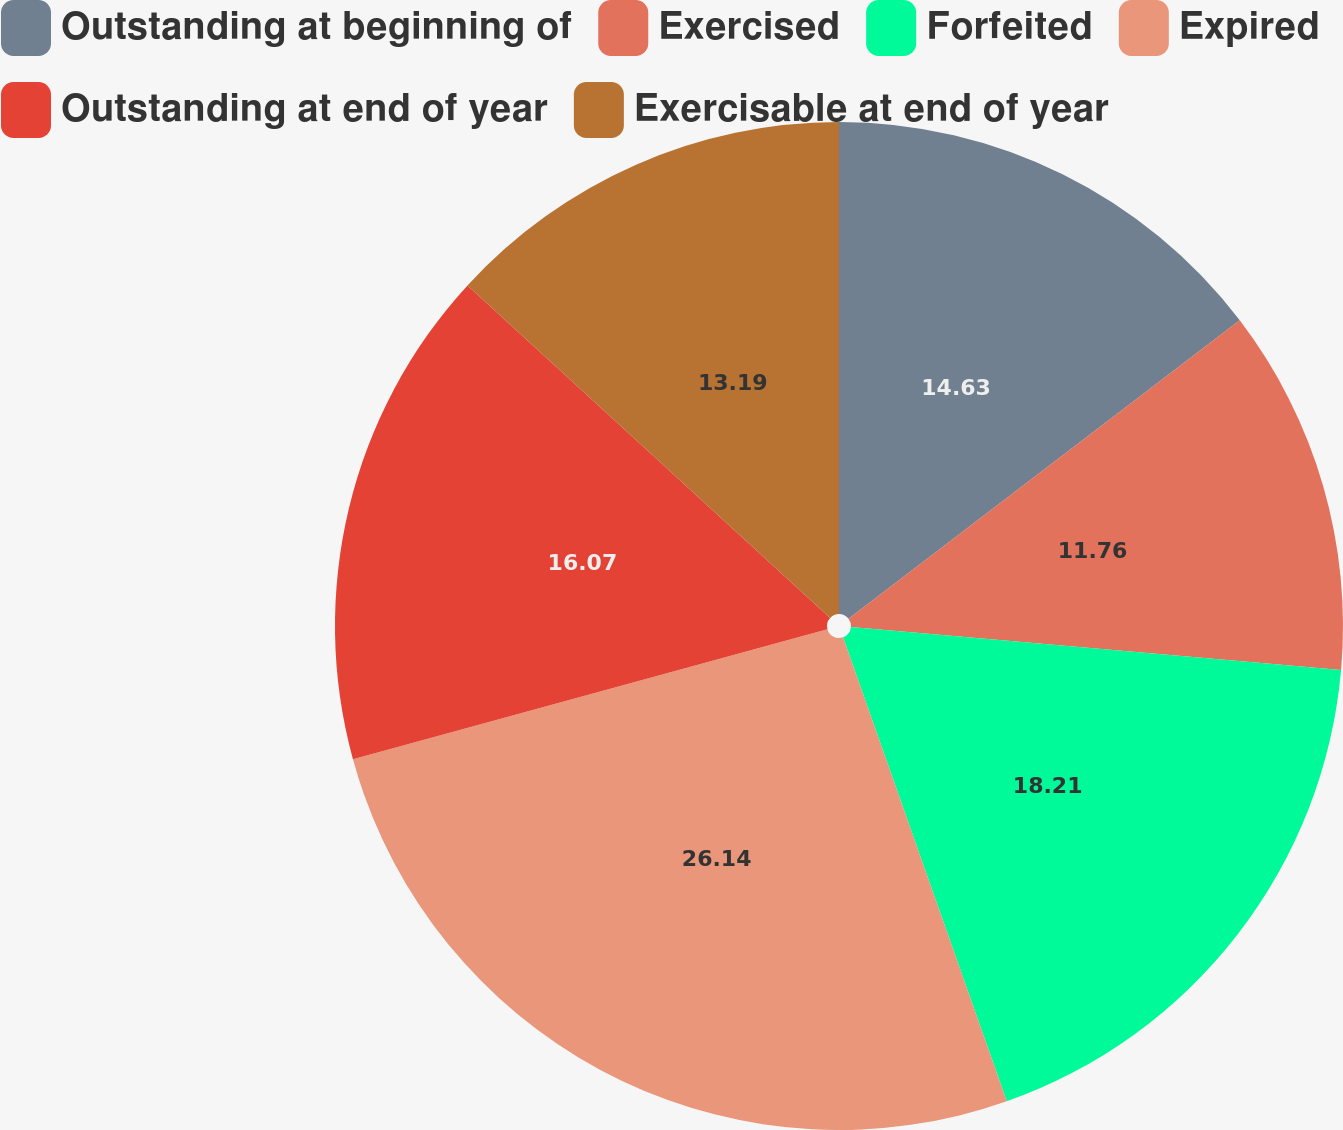Convert chart to OTSL. <chart><loc_0><loc_0><loc_500><loc_500><pie_chart><fcel>Outstanding at beginning of<fcel>Exercised<fcel>Forfeited<fcel>Expired<fcel>Outstanding at end of year<fcel>Exercisable at end of year<nl><fcel>14.63%<fcel>11.76%<fcel>18.21%<fcel>26.14%<fcel>16.07%<fcel>13.19%<nl></chart> 